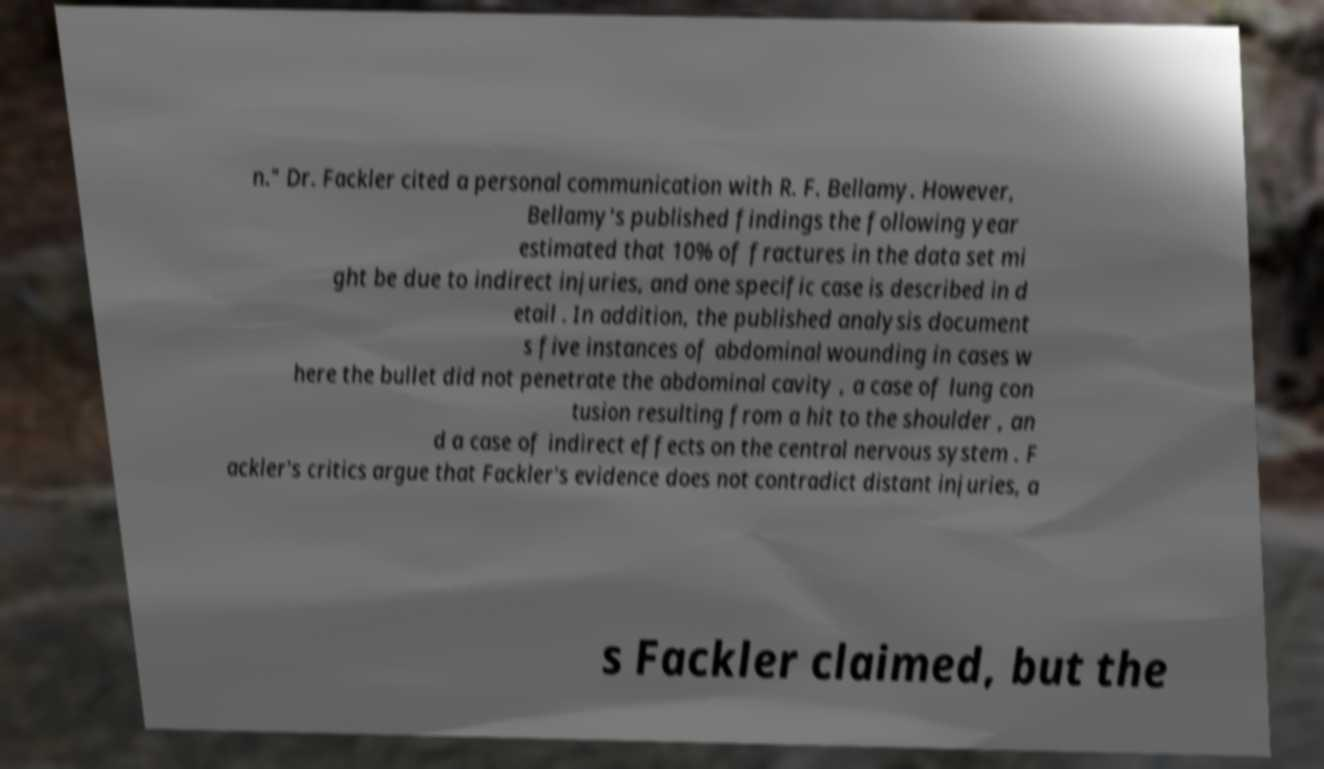There's text embedded in this image that I need extracted. Can you transcribe it verbatim? n." Dr. Fackler cited a personal communication with R. F. Bellamy. However, Bellamy's published findings the following year estimated that 10% of fractures in the data set mi ght be due to indirect injuries, and one specific case is described in d etail . In addition, the published analysis document s five instances of abdominal wounding in cases w here the bullet did not penetrate the abdominal cavity , a case of lung con tusion resulting from a hit to the shoulder , an d a case of indirect effects on the central nervous system . F ackler's critics argue that Fackler's evidence does not contradict distant injuries, a s Fackler claimed, but the 